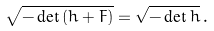<formula> <loc_0><loc_0><loc_500><loc_500>\sqrt { - \det { ( h + F ) } } = \sqrt { - \det { h } } \, .</formula> 